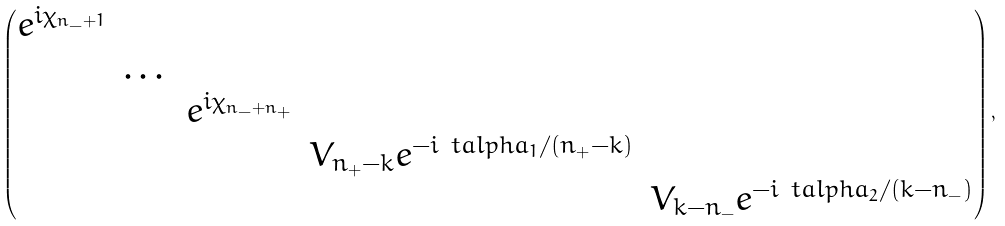Convert formula to latex. <formula><loc_0><loc_0><loc_500><loc_500>\begin{pmatrix} e ^ { i \chi _ { n _ { - } + 1 } } & & & & \\ & \dots & & & \\ & & e ^ { i \chi _ { n _ { - } + n _ { + } } } & & \\ & & & V _ { n _ { + } - k } e ^ { - i \ t a l p h a _ { 1 } / ( n _ { + } - k ) } & \\ & & & & V _ { k - n _ { - } } e ^ { - i \ t a l p h a _ { 2 } / ( k - n _ { - } ) } \end{pmatrix} ,</formula> 